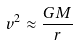Convert formula to latex. <formula><loc_0><loc_0><loc_500><loc_500>v ^ { 2 } \approx \frac { G M } { r }</formula> 